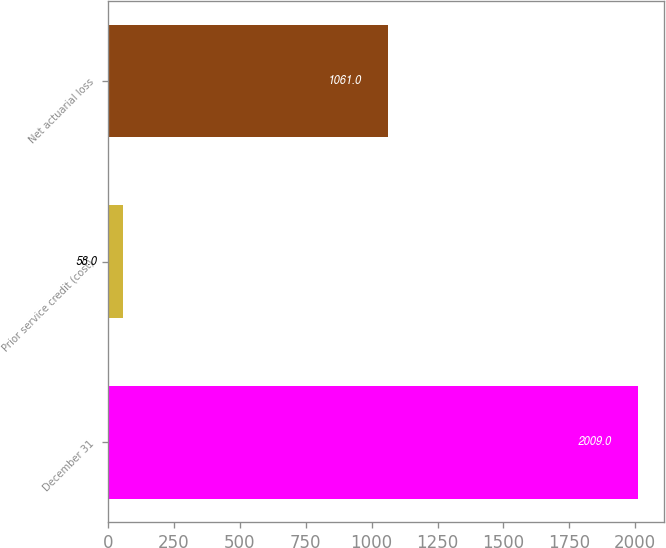Convert chart to OTSL. <chart><loc_0><loc_0><loc_500><loc_500><bar_chart><fcel>December 31<fcel>Prior service credit (cost)<fcel>Net actuarial loss<nl><fcel>2009<fcel>58<fcel>1061<nl></chart> 